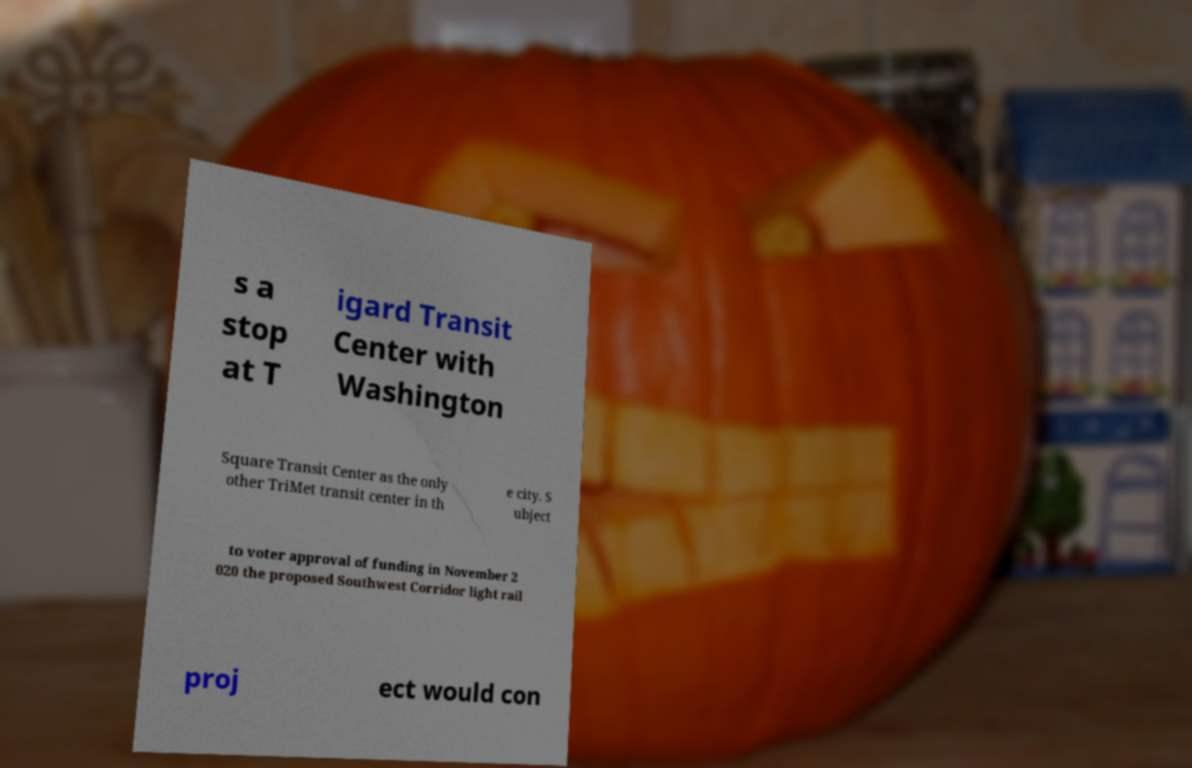Could you extract and type out the text from this image? s a stop at T igard Transit Center with Washington Square Transit Center as the only other TriMet transit center in th e city. S ubject to voter approval of funding in November 2 020 the proposed Southwest Corridor light rail proj ect would con 